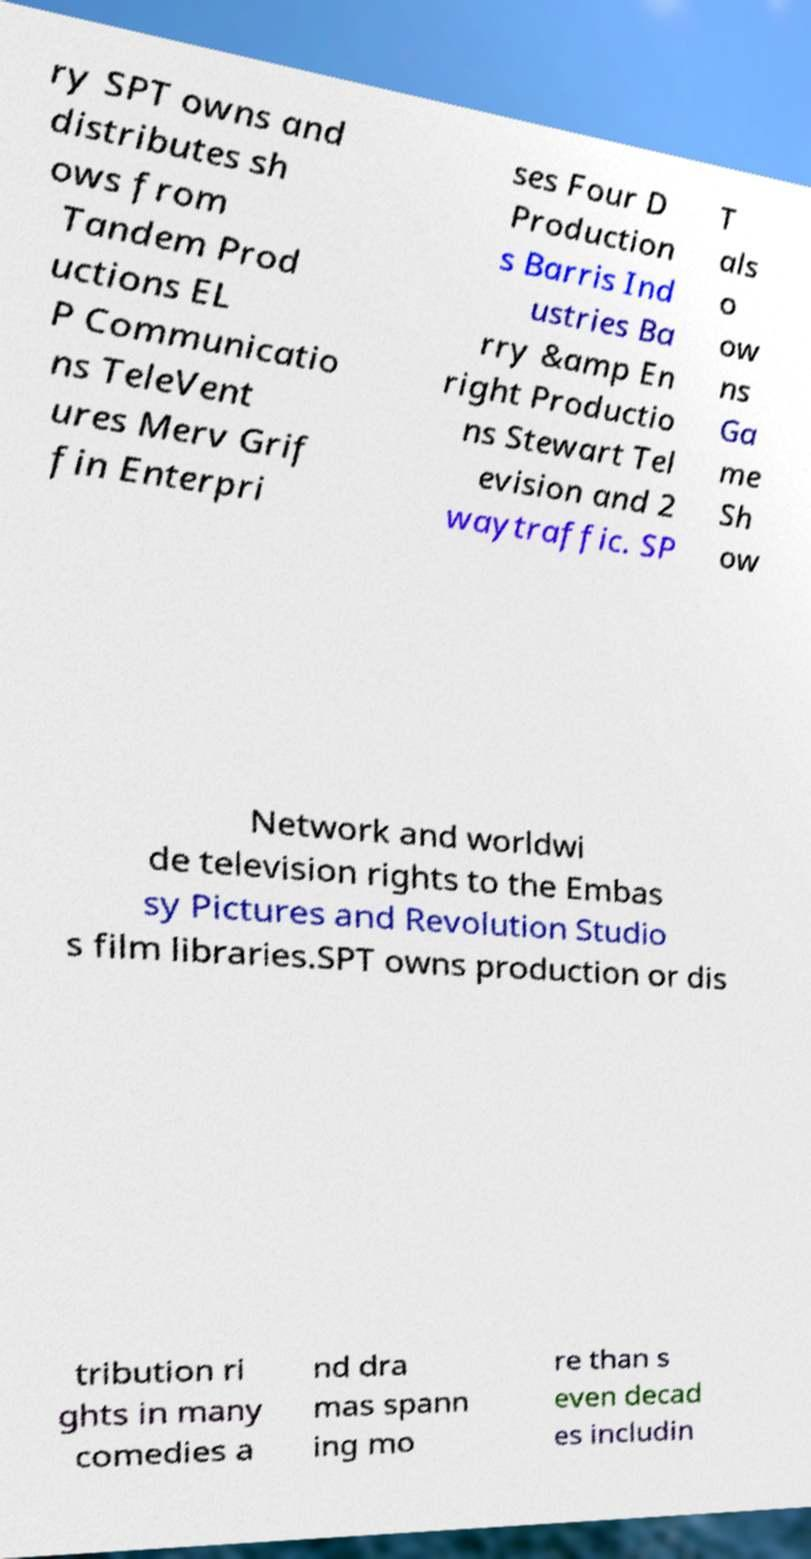Can you read and provide the text displayed in the image?This photo seems to have some interesting text. Can you extract and type it out for me? ry SPT owns and distributes sh ows from Tandem Prod uctions EL P Communicatio ns TeleVent ures Merv Grif fin Enterpri ses Four D Production s Barris Ind ustries Ba rry &amp En right Productio ns Stewart Tel evision and 2 waytraffic. SP T als o ow ns Ga me Sh ow Network and worldwi de television rights to the Embas sy Pictures and Revolution Studio s film libraries.SPT owns production or dis tribution ri ghts in many comedies a nd dra mas spann ing mo re than s even decad es includin 